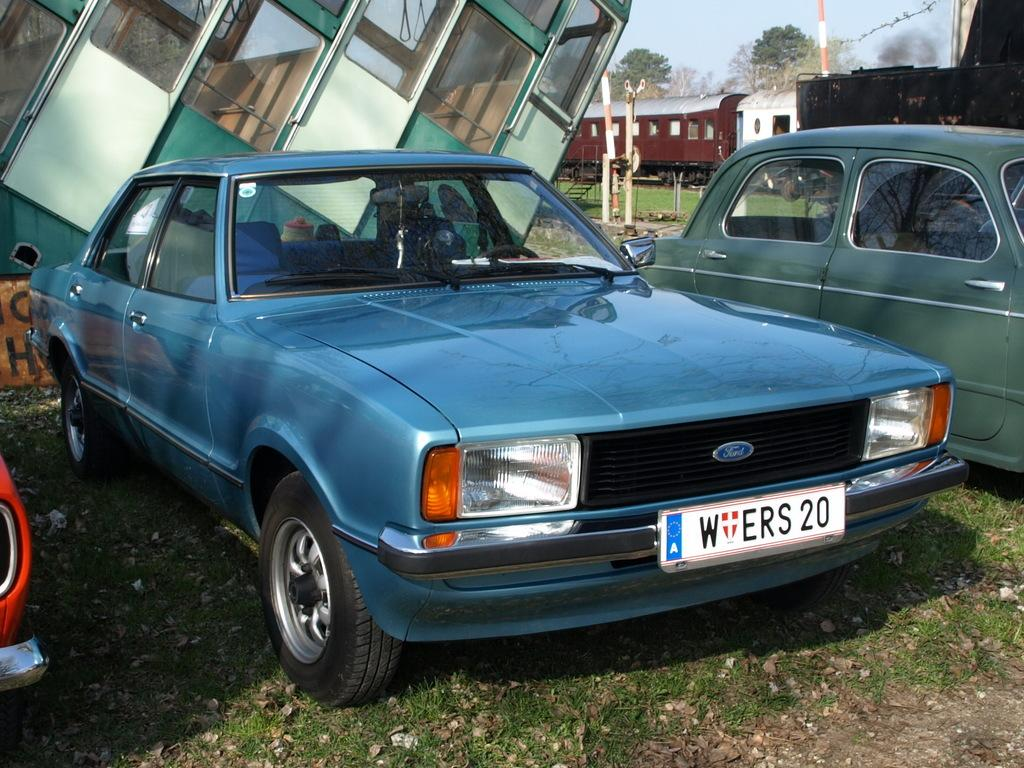What types of vehicles can be seen in the image? There are vehicles in the image, but the specific types are not mentioned. What is located on the track in the background of the image? There is a train on the track in the background of the image. What else can be seen in the background of the image? There are poles, trees, and the sky visible in the background of the image. What type of leather is used to make the seats of the vehicles in the image? There is no information about the vehicles' seats or the materials used to make them in the image. 